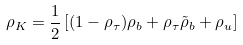<formula> <loc_0><loc_0><loc_500><loc_500>\rho _ { K } = \frac { 1 } { 2 } \left [ ( 1 - \rho _ { \tau } ) \rho _ { b } + \rho _ { \tau } \tilde { \rho } _ { b } + \rho _ { u } \right ]</formula> 